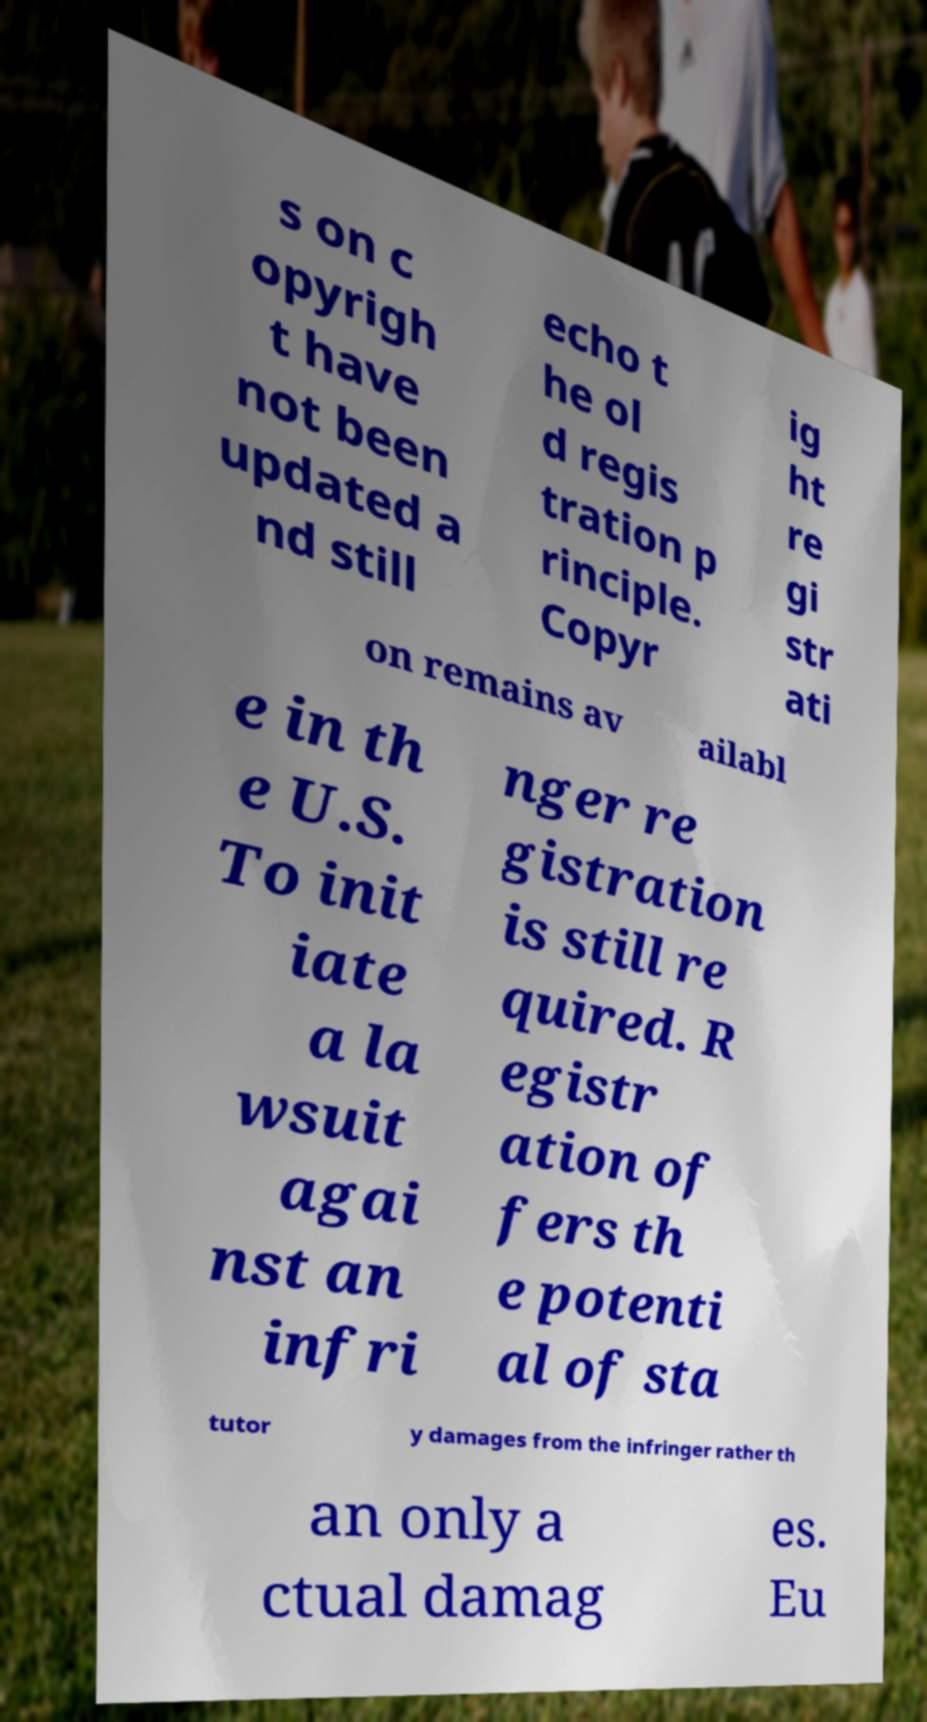What messages or text are displayed in this image? I need them in a readable, typed format. s on c opyrigh t have not been updated a nd still echo t he ol d regis tration p rinciple. Copyr ig ht re gi str ati on remains av ailabl e in th e U.S. To init iate a la wsuit agai nst an infri nger re gistration is still re quired. R egistr ation of fers th e potenti al of sta tutor y damages from the infringer rather th an only a ctual damag es. Eu 